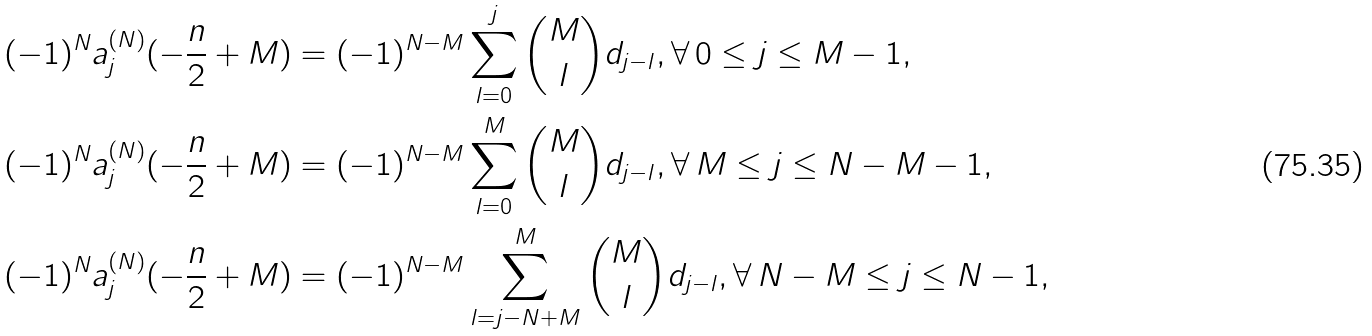<formula> <loc_0><loc_0><loc_500><loc_500>( - 1 ) ^ { N } a _ { j } ^ { ( N ) } & ( - \frac { n } { 2 } + M ) = ( - 1 ) ^ { N - M } \sum _ { l = 0 } ^ { j } { M \choose l } d _ { j - l } , \forall \, 0 \leq j \leq M - 1 , \\ ( - 1 ) ^ { N } a _ { j } ^ { ( N ) } & ( - \frac { n } { 2 } + M ) = ( - 1 ) ^ { N - M } \sum _ { l = 0 } ^ { M } { M \choose l } d _ { j - l } , \forall \, M \leq j \leq N - M - 1 , \\ ( - 1 ) ^ { N } a _ { j } ^ { ( N ) } & ( - \frac { n } { 2 } + M ) = ( - 1 ) ^ { N - M } \sum _ { l = j - N + M } ^ { M } { M \choose l } d _ { j - l } , \forall \, N - M \leq j \leq N - 1 ,</formula> 